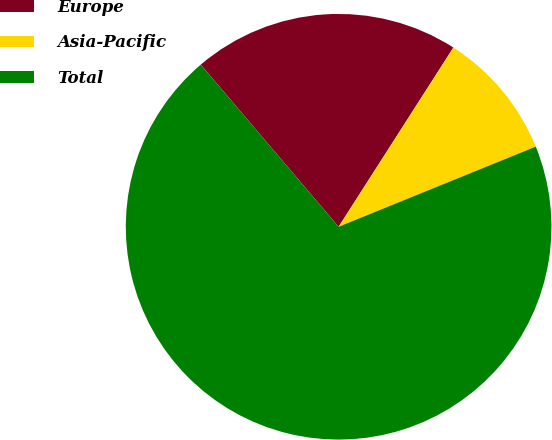Convert chart to OTSL. <chart><loc_0><loc_0><loc_500><loc_500><pie_chart><fcel>Europe<fcel>Asia-Pacific<fcel>Total<nl><fcel>20.28%<fcel>9.79%<fcel>69.93%<nl></chart> 